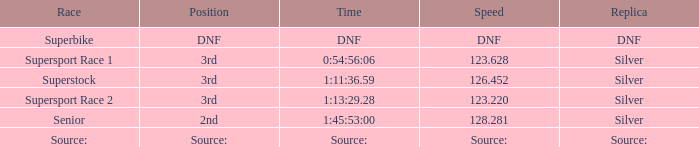Help me parse the entirety of this table. {'header': ['Race', 'Position', 'Time', 'Speed', 'Replica'], 'rows': [['Superbike', 'DNF', 'DNF', 'DNF', 'DNF'], ['Supersport Race 1', '3rd', '0:54:56:06', '123.628', 'Silver'], ['Superstock', '3rd', '1:11:36.59', '126.452', 'Silver'], ['Supersport Race 2', '3rd', '1:13:29.28', '123.220', 'Silver'], ['Senior', '2nd', '1:45:53:00', '128.281', 'Silver'], ['Source:', 'Source:', 'Source:', 'Source:', 'Source:']]} Which position has a time of 1:45:53:00? 2nd. 